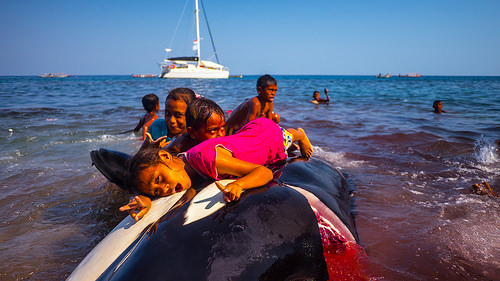<image>
Can you confirm if the child is behind the whale? No. The child is not behind the whale. From this viewpoint, the child appears to be positioned elsewhere in the scene. 